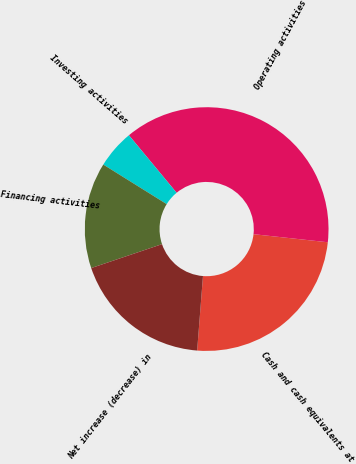Convert chart. <chart><loc_0><loc_0><loc_500><loc_500><pie_chart><fcel>Cash and cash equivalents at<fcel>Operating activities<fcel>Investing activities<fcel>Financing activities<fcel>Net increase (decrease) in<nl><fcel>24.52%<fcel>37.74%<fcel>5.11%<fcel>14.06%<fcel>18.57%<nl></chart> 